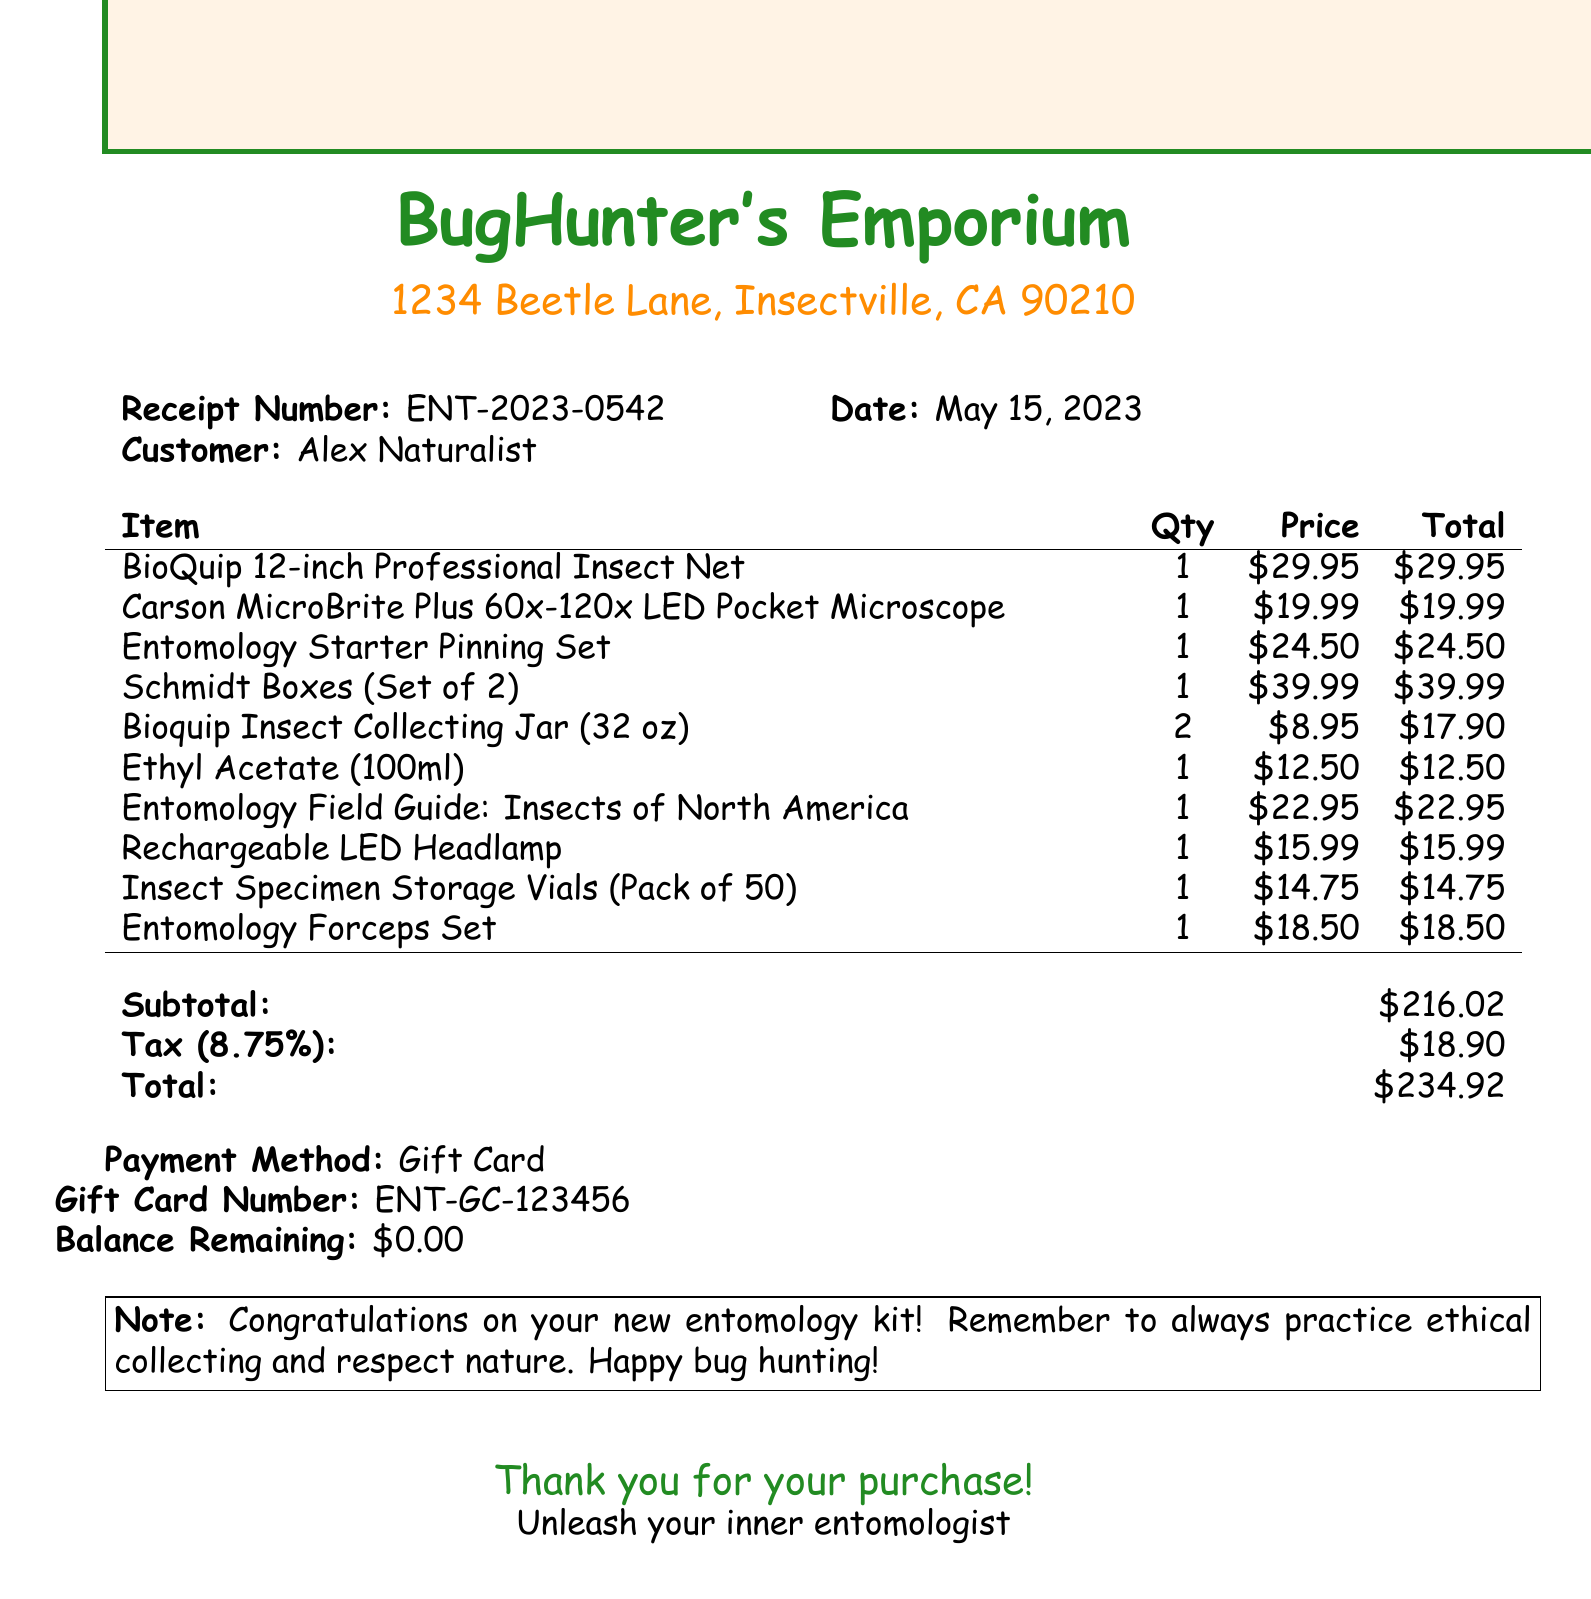What is the receipt number? The receipt number is a unique identifier for the transaction provided in the document.
Answer: ENT-2023-0542 What is the date of purchase? The date indicates when the transaction took place, mentioned in the document.
Answer: May 15, 2023 What is the total amount paid? The total amount is the final cost calculated, including tax, at the end of the document.
Answer: $234.92 How many Bioquip Insect Collecting Jars were purchased? The quantity of a specific item is listed in the items section of the document.
Answer: 2 What is the price of the Carson MicroBrite Plus microscope? The price for individual items is detailed in the document's item list.
Answer: $19.99 What payment method was used for this purchase? The payment method is indicated near the end of the document.
Answer: Gift Card What is the tax rate applied to the purchase? The tax rate is provided in the document, indicating the percentage applied to the subtotal.
Answer: 8.75% What is the total number of items purchased? The total number of items can be calculated by counting each item listed in the purchase.
Answer: 10 What note is included in the receipt? The note provides a message related to the purchase and is featured prominently at the end of the document.
Answer: Congratulations on your new entomology kit! Remember to always practice ethical collecting and respect nature. Happy bug hunting! 